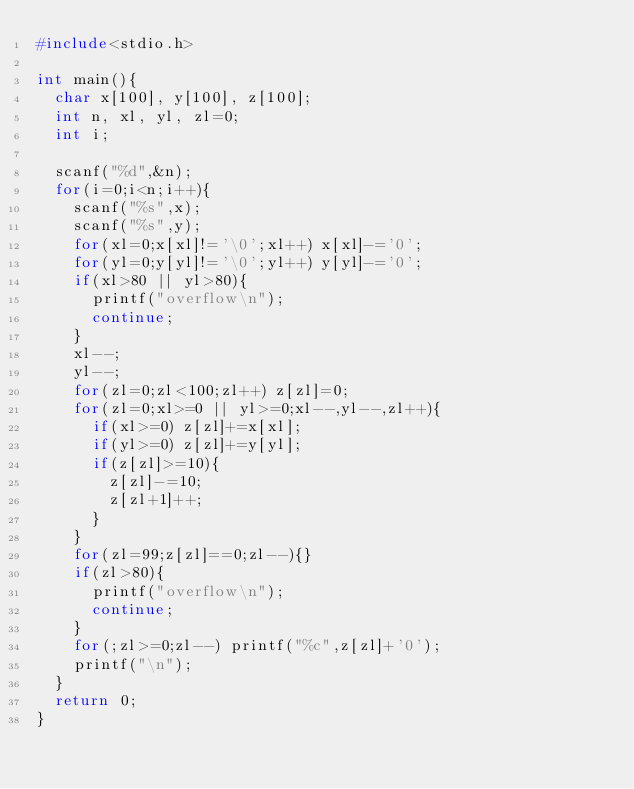<code> <loc_0><loc_0><loc_500><loc_500><_C_>#include<stdio.h>

int main(){
	char x[100], y[100], z[100];
	int n, xl, yl, zl=0;
	int i;

	scanf("%d",&n);
	for(i=0;i<n;i++){
		scanf("%s",x);
		scanf("%s",y);
		for(xl=0;x[xl]!='\0';xl++) x[xl]-='0';
		for(yl=0;y[yl]!='\0';yl++) y[yl]-='0';
		if(xl>80 || yl>80){
			printf("overflow\n");
			continue;
		}
		xl--;
		yl--;
		for(zl=0;zl<100;zl++) z[zl]=0;
		for(zl=0;xl>=0 || yl>=0;xl--,yl--,zl++){
			if(xl>=0) z[zl]+=x[xl];
			if(yl>=0) z[zl]+=y[yl];
			if(z[zl]>=10){
				z[zl]-=10;
				z[zl+1]++;
			}
		}
		for(zl=99;z[zl]==0;zl--){}
		if(zl>80){
			printf("overflow\n");
			continue;
		}
		for(;zl>=0;zl--) printf("%c",z[zl]+'0');
		printf("\n");
	}
	return 0;
}</code> 